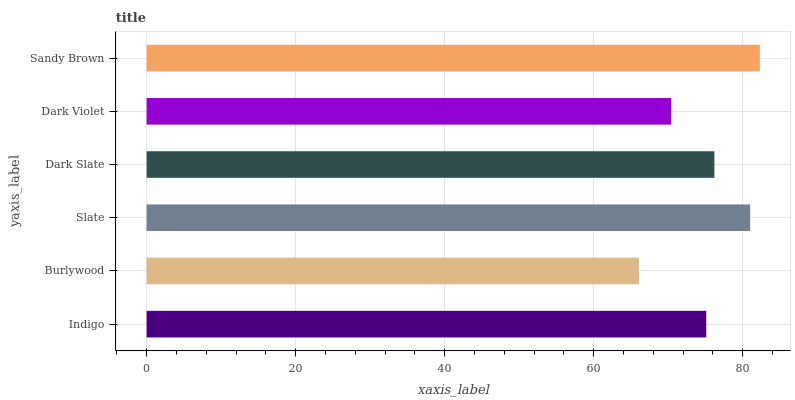Is Burlywood the minimum?
Answer yes or no. Yes. Is Sandy Brown the maximum?
Answer yes or no. Yes. Is Slate the minimum?
Answer yes or no. No. Is Slate the maximum?
Answer yes or no. No. Is Slate greater than Burlywood?
Answer yes or no. Yes. Is Burlywood less than Slate?
Answer yes or no. Yes. Is Burlywood greater than Slate?
Answer yes or no. No. Is Slate less than Burlywood?
Answer yes or no. No. Is Dark Slate the high median?
Answer yes or no. Yes. Is Indigo the low median?
Answer yes or no. Yes. Is Slate the high median?
Answer yes or no. No. Is Burlywood the low median?
Answer yes or no. No. 